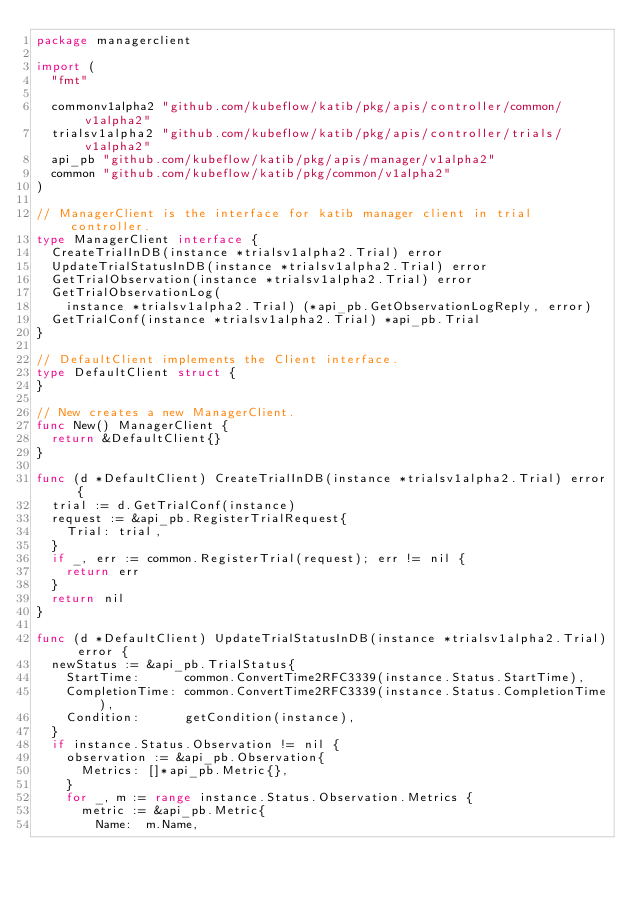Convert code to text. <code><loc_0><loc_0><loc_500><loc_500><_Go_>package managerclient

import (
	"fmt"

	commonv1alpha2 "github.com/kubeflow/katib/pkg/apis/controller/common/v1alpha2"
	trialsv1alpha2 "github.com/kubeflow/katib/pkg/apis/controller/trials/v1alpha2"
	api_pb "github.com/kubeflow/katib/pkg/apis/manager/v1alpha2"
	common "github.com/kubeflow/katib/pkg/common/v1alpha2"
)

// ManagerClient is the interface for katib manager client in trial controller.
type ManagerClient interface {
	CreateTrialInDB(instance *trialsv1alpha2.Trial) error
	UpdateTrialStatusInDB(instance *trialsv1alpha2.Trial) error
	GetTrialObservation(instance *trialsv1alpha2.Trial) error
	GetTrialObservationLog(
		instance *trialsv1alpha2.Trial) (*api_pb.GetObservationLogReply, error)
	GetTrialConf(instance *trialsv1alpha2.Trial) *api_pb.Trial
}

// DefaultClient implements the Client interface.
type DefaultClient struct {
}

// New creates a new ManagerClient.
func New() ManagerClient {
	return &DefaultClient{}
}

func (d *DefaultClient) CreateTrialInDB(instance *trialsv1alpha2.Trial) error {
	trial := d.GetTrialConf(instance)
	request := &api_pb.RegisterTrialRequest{
		Trial: trial,
	}
	if _, err := common.RegisterTrial(request); err != nil {
		return err
	}
	return nil
}

func (d *DefaultClient) UpdateTrialStatusInDB(instance *trialsv1alpha2.Trial) error {
	newStatus := &api_pb.TrialStatus{
		StartTime:      common.ConvertTime2RFC3339(instance.Status.StartTime),
		CompletionTime: common.ConvertTime2RFC3339(instance.Status.CompletionTime),
		Condition:      getCondition(instance),
	}
	if instance.Status.Observation != nil {
		observation := &api_pb.Observation{
			Metrics: []*api_pb.Metric{},
		}
		for _, m := range instance.Status.Observation.Metrics {
			metric := &api_pb.Metric{
				Name:  m.Name,</code> 